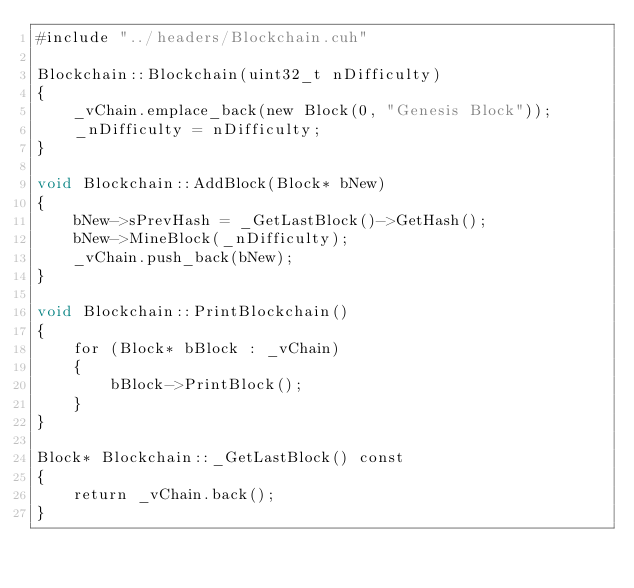<code> <loc_0><loc_0><loc_500><loc_500><_Cuda_>#include "../headers/Blockchain.cuh"

Blockchain::Blockchain(uint32_t nDifficulty)
{
	_vChain.emplace_back(new Block(0, "Genesis Block"));
	_nDifficulty = nDifficulty;
}

void Blockchain::AddBlock(Block* bNew)
{
	bNew->sPrevHash = _GetLastBlock()->GetHash();
	bNew->MineBlock(_nDifficulty);
	_vChain.push_back(bNew);
}

void Blockchain::PrintBlockchain()
{
	for (Block* bBlock : _vChain)
	{
		bBlock->PrintBlock();
	}
}

Block* Blockchain::_GetLastBlock() const
{
	return _vChain.back();
}</code> 